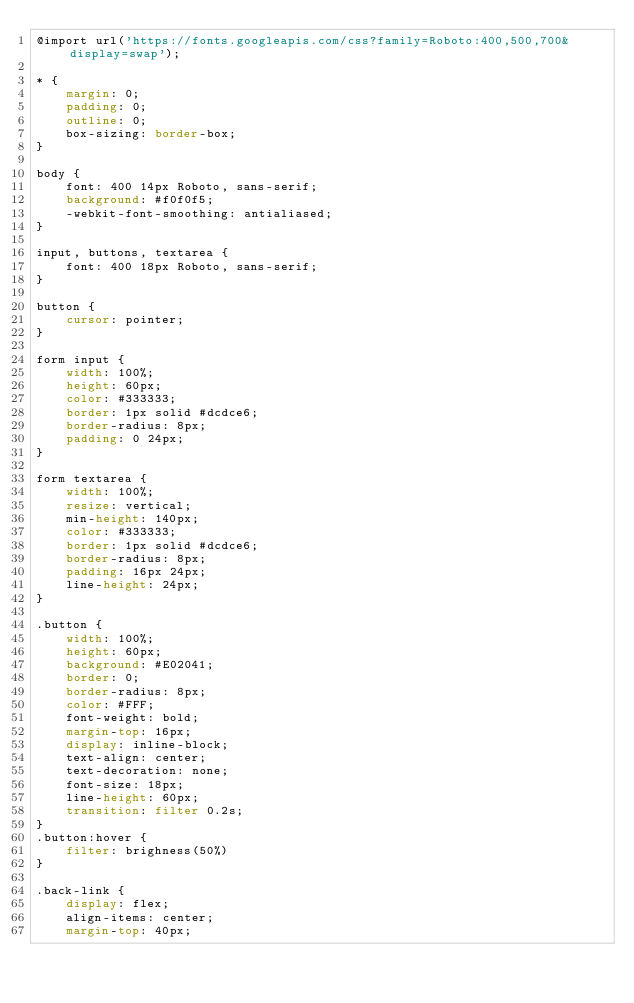Convert code to text. <code><loc_0><loc_0><loc_500><loc_500><_CSS_>@import url('https://fonts.googleapis.com/css?family=Roboto:400,500,700&display=swap');

* {
    margin: 0;
    padding: 0;
    outline: 0;
    box-sizing: border-box;
}

body {
    font: 400 14px Roboto, sans-serif;
    background: #f0f0f5;
    -webkit-font-smoothing: antialiased;
}

input, buttons, textarea {
    font: 400 18px Roboto, sans-serif;
}

button {
    cursor: pointer;
}

form input {
    width: 100%;
    height: 60px;
    color: #333333;
    border: 1px solid #dcdce6;
    border-radius: 8px;
    padding: 0 24px;
}

form textarea {
    width: 100%;
    resize: vertical;
    min-height: 140px;
    color: #333333;
    border: 1px solid #dcdce6;
    border-radius: 8px;
    padding: 16px 24px;
    line-height: 24px;
}

.button {
    width: 100%;
    height: 60px;
    background: #E02041;
    border: 0;
    border-radius: 8px;
    color: #FFF;
    font-weight: bold;
    margin-top: 16px;
    display: inline-block;
    text-align: center;
    text-decoration: none;
    font-size: 18px;
    line-height: 60px;
    transition: filter 0.2s;
}
.button:hover {
    filter: brighness(50%)
}

.back-link {
    display: flex;
    align-items: center;
    margin-top: 40px;</code> 